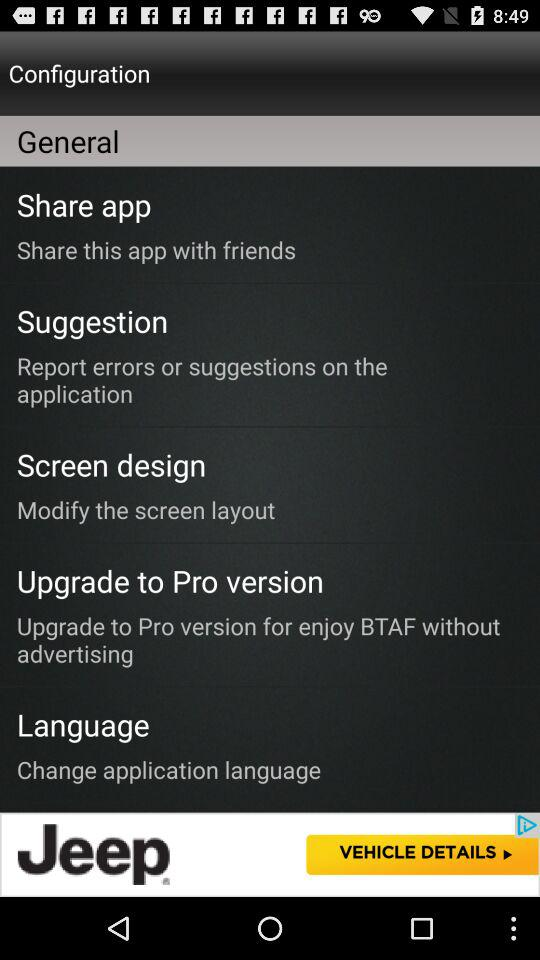How many menu items are there?
Answer the question using a single word or phrase. 4 